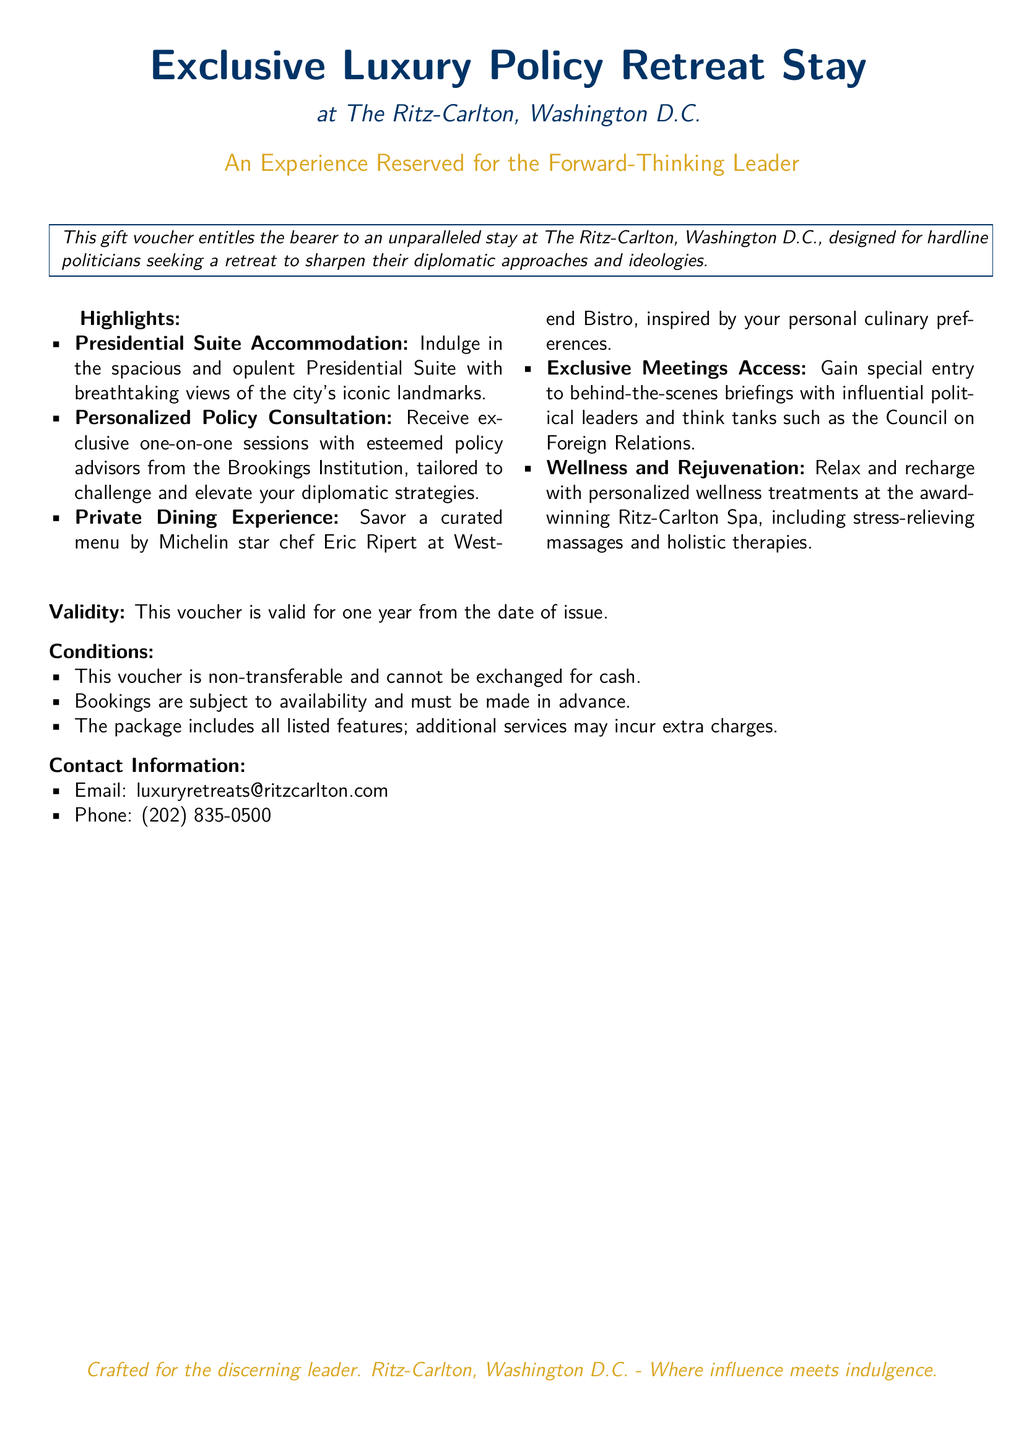What is the location of the retreat? The document states that the retreat is located at The Ritz-Carlton, Washington D.C.
Answer: The Ritz-Carlton, Washington D.C What is included in the voucher's highlights? The highlights list features five key offerings, including Presidential Suite Accommodation and Personalized Policy Consultation, among others.
Answer: Five key offerings What is the validity period of the voucher? The voucher is noted to be valid for one year from the date of issue.
Answer: One year What type of experience is specifically designed for politicians in the voucher? The voucher is designed for hardline politicians seeking to sharpen their diplomatic approaches and ideologies.
Answer: Hardline politicians What is the email contact provided in the document? The document includes an email contact for the retreat, which is provided for inquiries or booking.
Answer: luxuryretreats@ritzcarlton.com How many features are included in the package? The highlights section details five specific features included in the package offered by the voucher.
Answer: Five Are the bookings subject to availability? The conditions section explicitly states that bookings are subject to availability, indicating possible limitations on reservations.
Answer: Yes Is the voucher transferable? The conditions section underlines that the voucher is non-transferable, therefore cannot be given to someone else.
Answer: Non-transferable Which renowned chef is associated with the dining experience? The document mentions Michelin star chef Eric Ripert in connection with the dining experience offered in the retreat.
Answer: Eric Ripert 